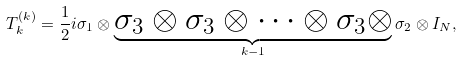<formula> <loc_0><loc_0><loc_500><loc_500>T _ { k } ^ { ( k ) } = { \frac { 1 } { 2 } } i \sigma _ { 1 } \otimes \underbrace { \sigma _ { 3 } \otimes \sigma _ { 3 } \otimes \dots \otimes \sigma _ { 3 } \otimes } _ { k - 1 } \sigma _ { 2 } \otimes I _ { N } ,</formula> 